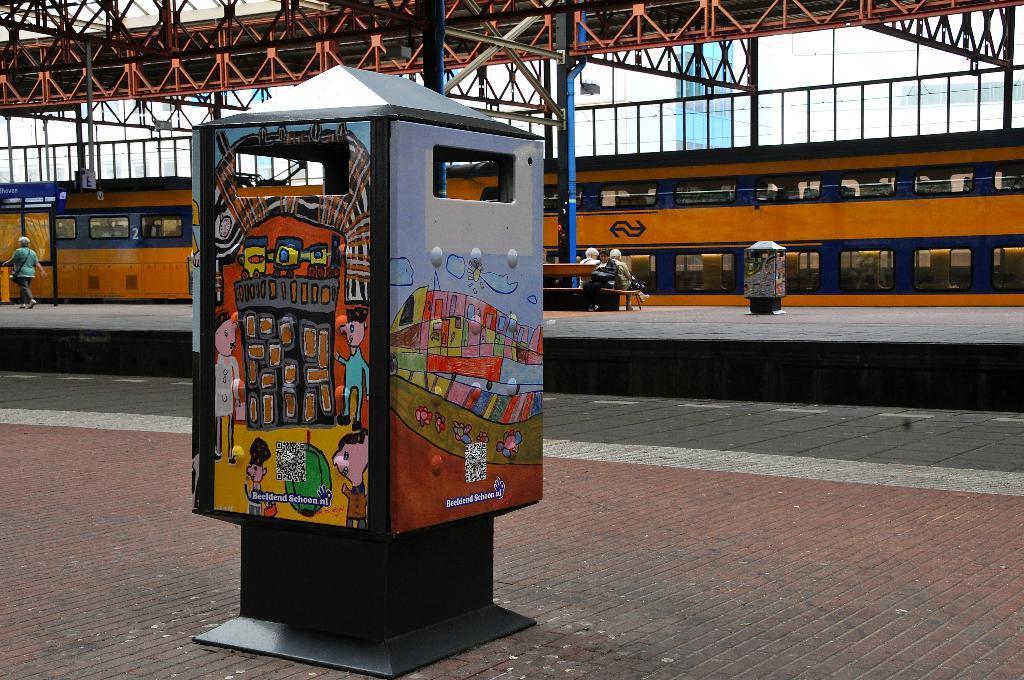Please provide a concise description of this image. In this image I can see a colourful thing in the front. In the background I can see a platform, a bench, a train, number of poles and on the bench I can see two persons are sitting. I can also see one person is walking on the left side of the image. 